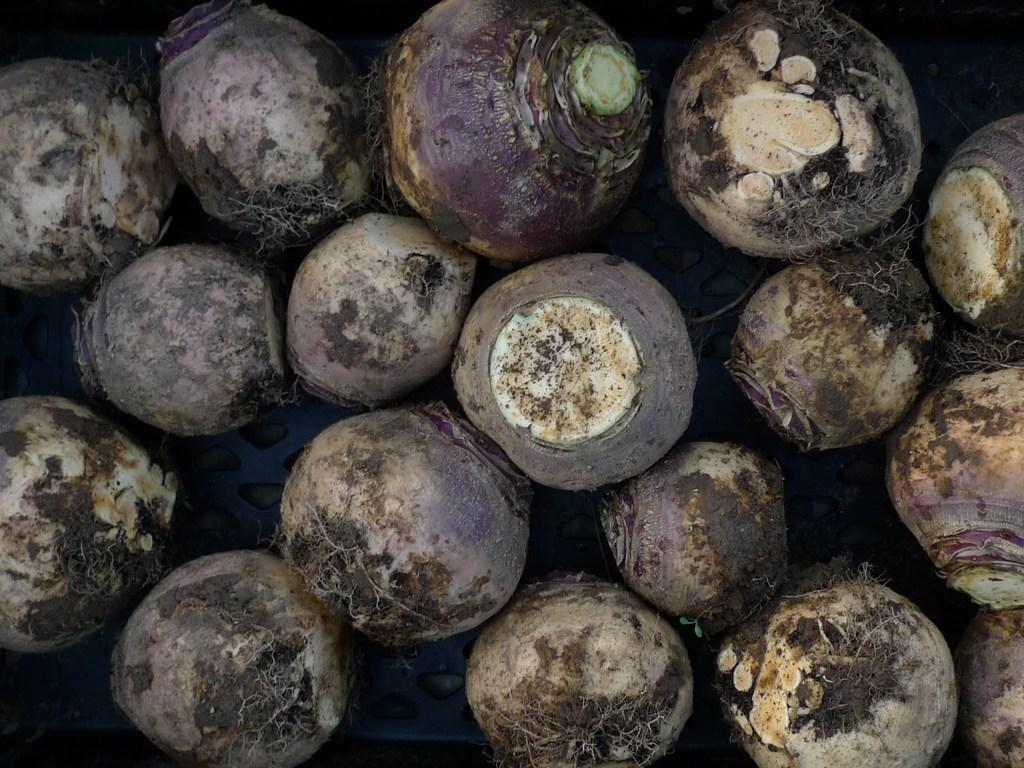What type of vegetable is present on the surface in the foreground of the image? There are beetroots on the surface in the foreground of the image. What type of property is visible in the background of the image? There is no property visible in the image; it only features beetroots on the surface in the foreground. How many rings are visible on the beetroots in the image? There are no rings present on the beetroots in the image. 